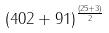Convert formula to latex. <formula><loc_0><loc_0><loc_500><loc_500>( 4 0 2 + 9 1 ) ^ { \frac { ( 2 5 + 3 ) } { 2 } }</formula> 